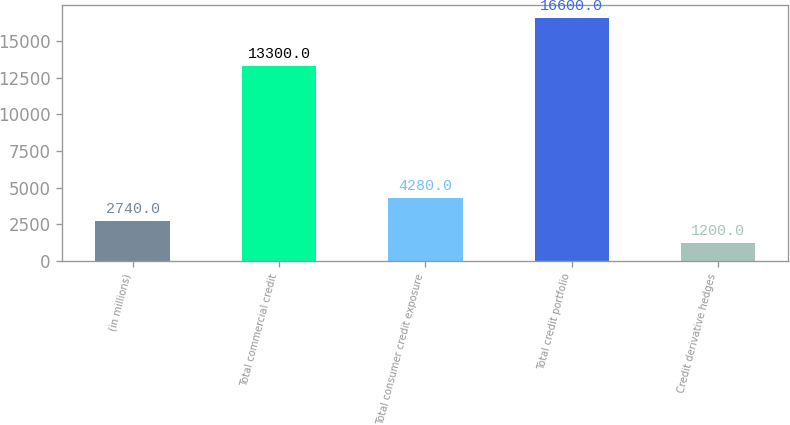Convert chart. <chart><loc_0><loc_0><loc_500><loc_500><bar_chart><fcel>(in millions)<fcel>Total commercial credit<fcel>Total consumer credit exposure<fcel>Total credit portfolio<fcel>Credit derivative hedges<nl><fcel>2740<fcel>13300<fcel>4280<fcel>16600<fcel>1200<nl></chart> 